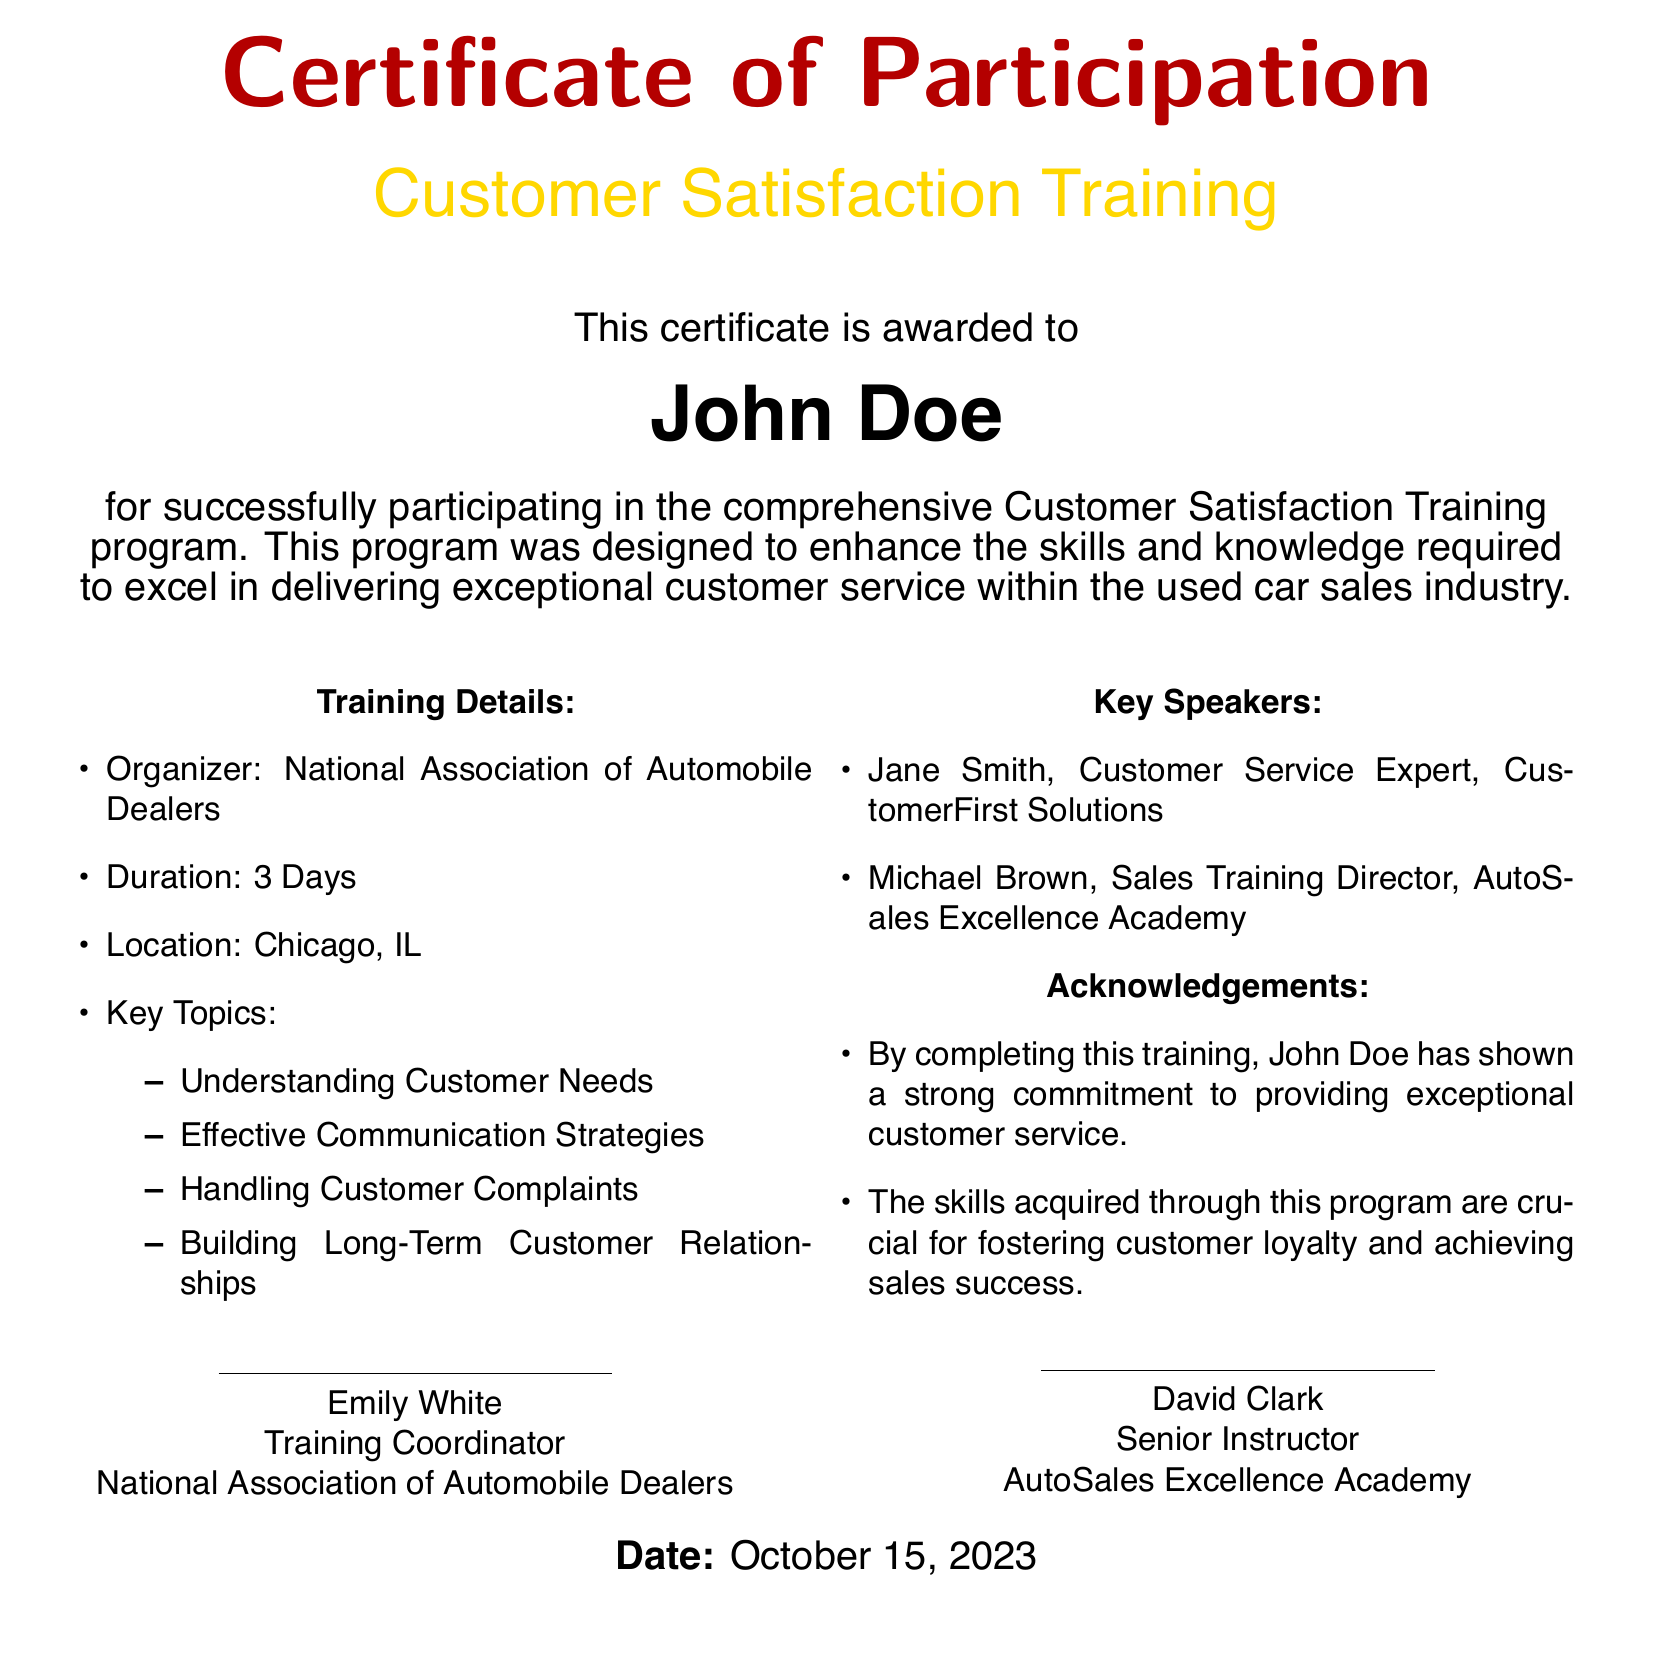what is the name of the person awarded the certificate? The document states that the certificate is awarded to John Doe.
Answer: John Doe what organization organized the training? The document indicates that the training was organized by the National Association of Automobile Dealers.
Answer: National Association of Automobile Dealers what was the duration of the training program? The document specifies that the training program lasted for 3 days.
Answer: 3 Days where did the training take place? The location mentioned in the document for the training is Chicago, IL.
Answer: Chicago, IL who was one of the key speakers at the training? The document lists Jane Smith as one of the key speakers at the training.
Answer: Jane Smith what is one of the key topics covered in the training? The document includes "Understanding Customer Needs" as one of the key topics.
Answer: Understanding Customer Needs on what date was the certificate issued? The document mentions the date the certificate was issued as October 15, 2023.
Answer: October 15, 2023 who is the Training Coordinator named in the certificate? The document identifies Emily White as the Training Coordinator.
Answer: Emily White what commitment has John Doe shown by completing the training? The document states he has shown a strong commitment to providing exceptional customer service.
Answer: Exceptional customer service how does the training contribute to sales success? The skills acquired through the training are crucial for fostering customer loyalty and achieving sales success.
Answer: Fostering customer loyalty 